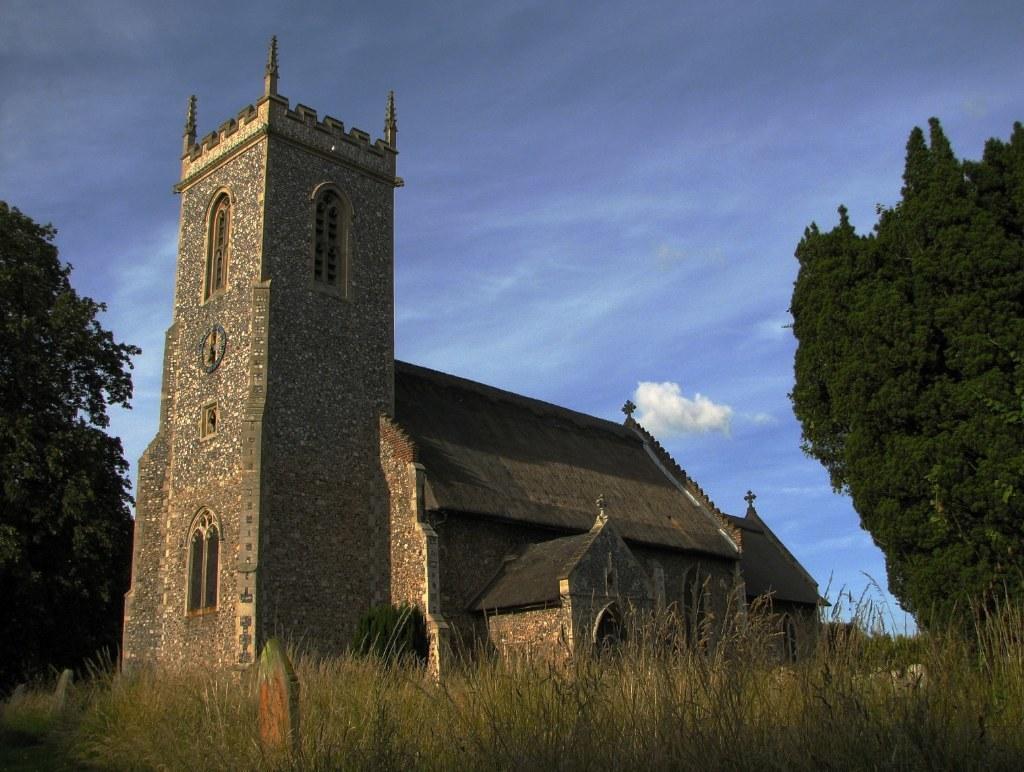In one or two sentences, can you explain what this image depicts? In this picture we can see a building. There is a tree on the left side. We can see another tree on the right side. Some grass is visible on the ground. Sky is blue in color and cloudy. 